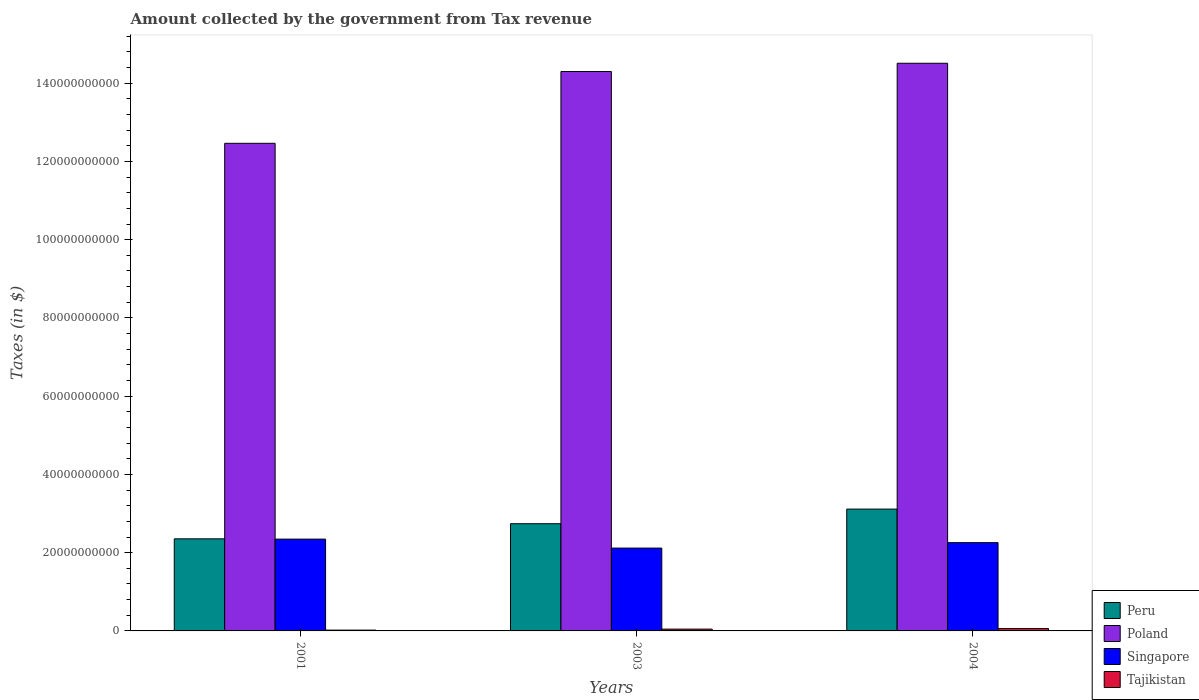How many different coloured bars are there?
Give a very brief answer. 4. How many groups of bars are there?
Provide a short and direct response. 3. Are the number of bars on each tick of the X-axis equal?
Keep it short and to the point. Yes. What is the amount collected by the government from tax revenue in Singapore in 2001?
Provide a succinct answer. 2.35e+1. Across all years, what is the maximum amount collected by the government from tax revenue in Singapore?
Provide a succinct answer. 2.35e+1. Across all years, what is the minimum amount collected by the government from tax revenue in Poland?
Offer a very short reply. 1.25e+11. In which year was the amount collected by the government from tax revenue in Tajikistan maximum?
Offer a very short reply. 2004. What is the total amount collected by the government from tax revenue in Peru in the graph?
Provide a succinct answer. 8.21e+1. What is the difference between the amount collected by the government from tax revenue in Peru in 2001 and that in 2003?
Your answer should be very brief. -3.86e+09. What is the difference between the amount collected by the government from tax revenue in Tajikistan in 2003 and the amount collected by the government from tax revenue in Poland in 2004?
Your answer should be compact. -1.45e+11. What is the average amount collected by the government from tax revenue in Poland per year?
Provide a succinct answer. 1.38e+11. In the year 2003, what is the difference between the amount collected by the government from tax revenue in Singapore and amount collected by the government from tax revenue in Poland?
Your answer should be compact. -1.22e+11. In how many years, is the amount collected by the government from tax revenue in Singapore greater than 52000000000 $?
Keep it short and to the point. 0. What is the ratio of the amount collected by the government from tax revenue in Singapore in 2001 to that in 2003?
Your answer should be very brief. 1.11. What is the difference between the highest and the second highest amount collected by the government from tax revenue in Singapore?
Give a very brief answer. 9.03e+08. What is the difference between the highest and the lowest amount collected by the government from tax revenue in Singapore?
Your answer should be compact. 2.29e+09. In how many years, is the amount collected by the government from tax revenue in Tajikistan greater than the average amount collected by the government from tax revenue in Tajikistan taken over all years?
Your answer should be very brief. 2. What does the 4th bar from the left in 2004 represents?
Ensure brevity in your answer.  Tajikistan. How many bars are there?
Your answer should be compact. 12. Does the graph contain grids?
Keep it short and to the point. No. What is the title of the graph?
Keep it short and to the point. Amount collected by the government from Tax revenue. What is the label or title of the Y-axis?
Ensure brevity in your answer.  Taxes (in $). What is the Taxes (in $) in Peru in 2001?
Give a very brief answer. 2.35e+1. What is the Taxes (in $) in Poland in 2001?
Make the answer very short. 1.25e+11. What is the Taxes (in $) of Singapore in 2001?
Offer a terse response. 2.35e+1. What is the Taxes (in $) of Tajikistan in 2001?
Provide a succinct answer. 2.10e+08. What is the Taxes (in $) in Peru in 2003?
Provide a short and direct response. 2.74e+1. What is the Taxes (in $) of Poland in 2003?
Offer a terse response. 1.43e+11. What is the Taxes (in $) in Singapore in 2003?
Your answer should be compact. 2.12e+1. What is the Taxes (in $) in Tajikistan in 2003?
Provide a short and direct response. 4.62e+08. What is the Taxes (in $) in Peru in 2004?
Keep it short and to the point. 3.11e+1. What is the Taxes (in $) in Poland in 2004?
Offer a terse response. 1.45e+11. What is the Taxes (in $) in Singapore in 2004?
Make the answer very short. 2.26e+1. What is the Taxes (in $) in Tajikistan in 2004?
Keep it short and to the point. 6.06e+08. Across all years, what is the maximum Taxes (in $) of Peru?
Provide a short and direct response. 3.11e+1. Across all years, what is the maximum Taxes (in $) of Poland?
Provide a short and direct response. 1.45e+11. Across all years, what is the maximum Taxes (in $) of Singapore?
Provide a succinct answer. 2.35e+1. Across all years, what is the maximum Taxes (in $) in Tajikistan?
Your answer should be compact. 6.06e+08. Across all years, what is the minimum Taxes (in $) of Peru?
Provide a succinct answer. 2.35e+1. Across all years, what is the minimum Taxes (in $) in Poland?
Your answer should be very brief. 1.25e+11. Across all years, what is the minimum Taxes (in $) in Singapore?
Your answer should be compact. 2.12e+1. Across all years, what is the minimum Taxes (in $) of Tajikistan?
Offer a very short reply. 2.10e+08. What is the total Taxes (in $) in Peru in the graph?
Your response must be concise. 8.21e+1. What is the total Taxes (in $) in Poland in the graph?
Provide a succinct answer. 4.13e+11. What is the total Taxes (in $) in Singapore in the graph?
Ensure brevity in your answer.  6.72e+1. What is the total Taxes (in $) of Tajikistan in the graph?
Keep it short and to the point. 1.28e+09. What is the difference between the Taxes (in $) in Peru in 2001 and that in 2003?
Your answer should be very brief. -3.86e+09. What is the difference between the Taxes (in $) of Poland in 2001 and that in 2003?
Provide a short and direct response. -1.83e+1. What is the difference between the Taxes (in $) in Singapore in 2001 and that in 2003?
Make the answer very short. 2.29e+09. What is the difference between the Taxes (in $) of Tajikistan in 2001 and that in 2003?
Offer a terse response. -2.52e+08. What is the difference between the Taxes (in $) in Peru in 2001 and that in 2004?
Your answer should be very brief. -7.60e+09. What is the difference between the Taxes (in $) of Poland in 2001 and that in 2004?
Provide a short and direct response. -2.05e+1. What is the difference between the Taxes (in $) of Singapore in 2001 and that in 2004?
Provide a succinct answer. 9.03e+08. What is the difference between the Taxes (in $) in Tajikistan in 2001 and that in 2004?
Your answer should be very brief. -3.95e+08. What is the difference between the Taxes (in $) in Peru in 2003 and that in 2004?
Your response must be concise. -3.74e+09. What is the difference between the Taxes (in $) of Poland in 2003 and that in 2004?
Your response must be concise. -2.11e+09. What is the difference between the Taxes (in $) in Singapore in 2003 and that in 2004?
Your answer should be very brief. -1.39e+09. What is the difference between the Taxes (in $) in Tajikistan in 2003 and that in 2004?
Keep it short and to the point. -1.44e+08. What is the difference between the Taxes (in $) in Peru in 2001 and the Taxes (in $) in Poland in 2003?
Give a very brief answer. -1.19e+11. What is the difference between the Taxes (in $) of Peru in 2001 and the Taxes (in $) of Singapore in 2003?
Offer a terse response. 2.37e+09. What is the difference between the Taxes (in $) of Peru in 2001 and the Taxes (in $) of Tajikistan in 2003?
Give a very brief answer. 2.31e+1. What is the difference between the Taxes (in $) in Poland in 2001 and the Taxes (in $) in Singapore in 2003?
Provide a short and direct response. 1.03e+11. What is the difference between the Taxes (in $) in Poland in 2001 and the Taxes (in $) in Tajikistan in 2003?
Keep it short and to the point. 1.24e+11. What is the difference between the Taxes (in $) in Singapore in 2001 and the Taxes (in $) in Tajikistan in 2003?
Offer a very short reply. 2.30e+1. What is the difference between the Taxes (in $) of Peru in 2001 and the Taxes (in $) of Poland in 2004?
Ensure brevity in your answer.  -1.22e+11. What is the difference between the Taxes (in $) in Peru in 2001 and the Taxes (in $) in Singapore in 2004?
Provide a short and direct response. 9.78e+08. What is the difference between the Taxes (in $) in Peru in 2001 and the Taxes (in $) in Tajikistan in 2004?
Provide a short and direct response. 2.29e+1. What is the difference between the Taxes (in $) of Poland in 2001 and the Taxes (in $) of Singapore in 2004?
Your answer should be very brief. 1.02e+11. What is the difference between the Taxes (in $) of Poland in 2001 and the Taxes (in $) of Tajikistan in 2004?
Your answer should be very brief. 1.24e+11. What is the difference between the Taxes (in $) in Singapore in 2001 and the Taxes (in $) in Tajikistan in 2004?
Keep it short and to the point. 2.29e+1. What is the difference between the Taxes (in $) of Peru in 2003 and the Taxes (in $) of Poland in 2004?
Give a very brief answer. -1.18e+11. What is the difference between the Taxes (in $) of Peru in 2003 and the Taxes (in $) of Singapore in 2004?
Ensure brevity in your answer.  4.84e+09. What is the difference between the Taxes (in $) of Peru in 2003 and the Taxes (in $) of Tajikistan in 2004?
Your response must be concise. 2.68e+1. What is the difference between the Taxes (in $) of Poland in 2003 and the Taxes (in $) of Singapore in 2004?
Give a very brief answer. 1.20e+11. What is the difference between the Taxes (in $) of Poland in 2003 and the Taxes (in $) of Tajikistan in 2004?
Provide a succinct answer. 1.42e+11. What is the difference between the Taxes (in $) of Singapore in 2003 and the Taxes (in $) of Tajikistan in 2004?
Give a very brief answer. 2.06e+1. What is the average Taxes (in $) in Peru per year?
Make the answer very short. 2.74e+1. What is the average Taxes (in $) in Poland per year?
Provide a short and direct response. 1.38e+11. What is the average Taxes (in $) of Singapore per year?
Your response must be concise. 2.24e+1. What is the average Taxes (in $) in Tajikistan per year?
Offer a terse response. 4.26e+08. In the year 2001, what is the difference between the Taxes (in $) in Peru and Taxes (in $) in Poland?
Your answer should be compact. -1.01e+11. In the year 2001, what is the difference between the Taxes (in $) in Peru and Taxes (in $) in Singapore?
Offer a terse response. 7.47e+07. In the year 2001, what is the difference between the Taxes (in $) of Peru and Taxes (in $) of Tajikistan?
Provide a succinct answer. 2.33e+1. In the year 2001, what is the difference between the Taxes (in $) of Poland and Taxes (in $) of Singapore?
Provide a succinct answer. 1.01e+11. In the year 2001, what is the difference between the Taxes (in $) in Poland and Taxes (in $) in Tajikistan?
Give a very brief answer. 1.24e+11. In the year 2001, what is the difference between the Taxes (in $) of Singapore and Taxes (in $) of Tajikistan?
Keep it short and to the point. 2.33e+1. In the year 2003, what is the difference between the Taxes (in $) in Peru and Taxes (in $) in Poland?
Make the answer very short. -1.16e+11. In the year 2003, what is the difference between the Taxes (in $) of Peru and Taxes (in $) of Singapore?
Your response must be concise. 6.23e+09. In the year 2003, what is the difference between the Taxes (in $) of Peru and Taxes (in $) of Tajikistan?
Ensure brevity in your answer.  2.69e+1. In the year 2003, what is the difference between the Taxes (in $) in Poland and Taxes (in $) in Singapore?
Give a very brief answer. 1.22e+11. In the year 2003, what is the difference between the Taxes (in $) in Poland and Taxes (in $) in Tajikistan?
Ensure brevity in your answer.  1.43e+11. In the year 2003, what is the difference between the Taxes (in $) of Singapore and Taxes (in $) of Tajikistan?
Your answer should be very brief. 2.07e+1. In the year 2004, what is the difference between the Taxes (in $) in Peru and Taxes (in $) in Poland?
Ensure brevity in your answer.  -1.14e+11. In the year 2004, what is the difference between the Taxes (in $) of Peru and Taxes (in $) of Singapore?
Provide a short and direct response. 8.58e+09. In the year 2004, what is the difference between the Taxes (in $) of Peru and Taxes (in $) of Tajikistan?
Keep it short and to the point. 3.05e+1. In the year 2004, what is the difference between the Taxes (in $) in Poland and Taxes (in $) in Singapore?
Your answer should be compact. 1.23e+11. In the year 2004, what is the difference between the Taxes (in $) in Poland and Taxes (in $) in Tajikistan?
Give a very brief answer. 1.44e+11. In the year 2004, what is the difference between the Taxes (in $) in Singapore and Taxes (in $) in Tajikistan?
Give a very brief answer. 2.20e+1. What is the ratio of the Taxes (in $) in Peru in 2001 to that in 2003?
Make the answer very short. 0.86. What is the ratio of the Taxes (in $) in Poland in 2001 to that in 2003?
Offer a very short reply. 0.87. What is the ratio of the Taxes (in $) of Singapore in 2001 to that in 2003?
Your response must be concise. 1.11. What is the ratio of the Taxes (in $) of Tajikistan in 2001 to that in 2003?
Provide a short and direct response. 0.46. What is the ratio of the Taxes (in $) of Peru in 2001 to that in 2004?
Make the answer very short. 0.76. What is the ratio of the Taxes (in $) of Poland in 2001 to that in 2004?
Your answer should be very brief. 0.86. What is the ratio of the Taxes (in $) of Singapore in 2001 to that in 2004?
Your response must be concise. 1.04. What is the ratio of the Taxes (in $) of Tajikistan in 2001 to that in 2004?
Offer a very short reply. 0.35. What is the ratio of the Taxes (in $) in Peru in 2003 to that in 2004?
Provide a short and direct response. 0.88. What is the ratio of the Taxes (in $) in Poland in 2003 to that in 2004?
Keep it short and to the point. 0.99. What is the ratio of the Taxes (in $) of Singapore in 2003 to that in 2004?
Keep it short and to the point. 0.94. What is the ratio of the Taxes (in $) in Tajikistan in 2003 to that in 2004?
Your answer should be compact. 0.76. What is the difference between the highest and the second highest Taxes (in $) in Peru?
Provide a short and direct response. 3.74e+09. What is the difference between the highest and the second highest Taxes (in $) of Poland?
Your answer should be compact. 2.11e+09. What is the difference between the highest and the second highest Taxes (in $) of Singapore?
Give a very brief answer. 9.03e+08. What is the difference between the highest and the second highest Taxes (in $) of Tajikistan?
Offer a very short reply. 1.44e+08. What is the difference between the highest and the lowest Taxes (in $) in Peru?
Make the answer very short. 7.60e+09. What is the difference between the highest and the lowest Taxes (in $) of Poland?
Your answer should be very brief. 2.05e+1. What is the difference between the highest and the lowest Taxes (in $) in Singapore?
Provide a succinct answer. 2.29e+09. What is the difference between the highest and the lowest Taxes (in $) of Tajikistan?
Ensure brevity in your answer.  3.95e+08. 